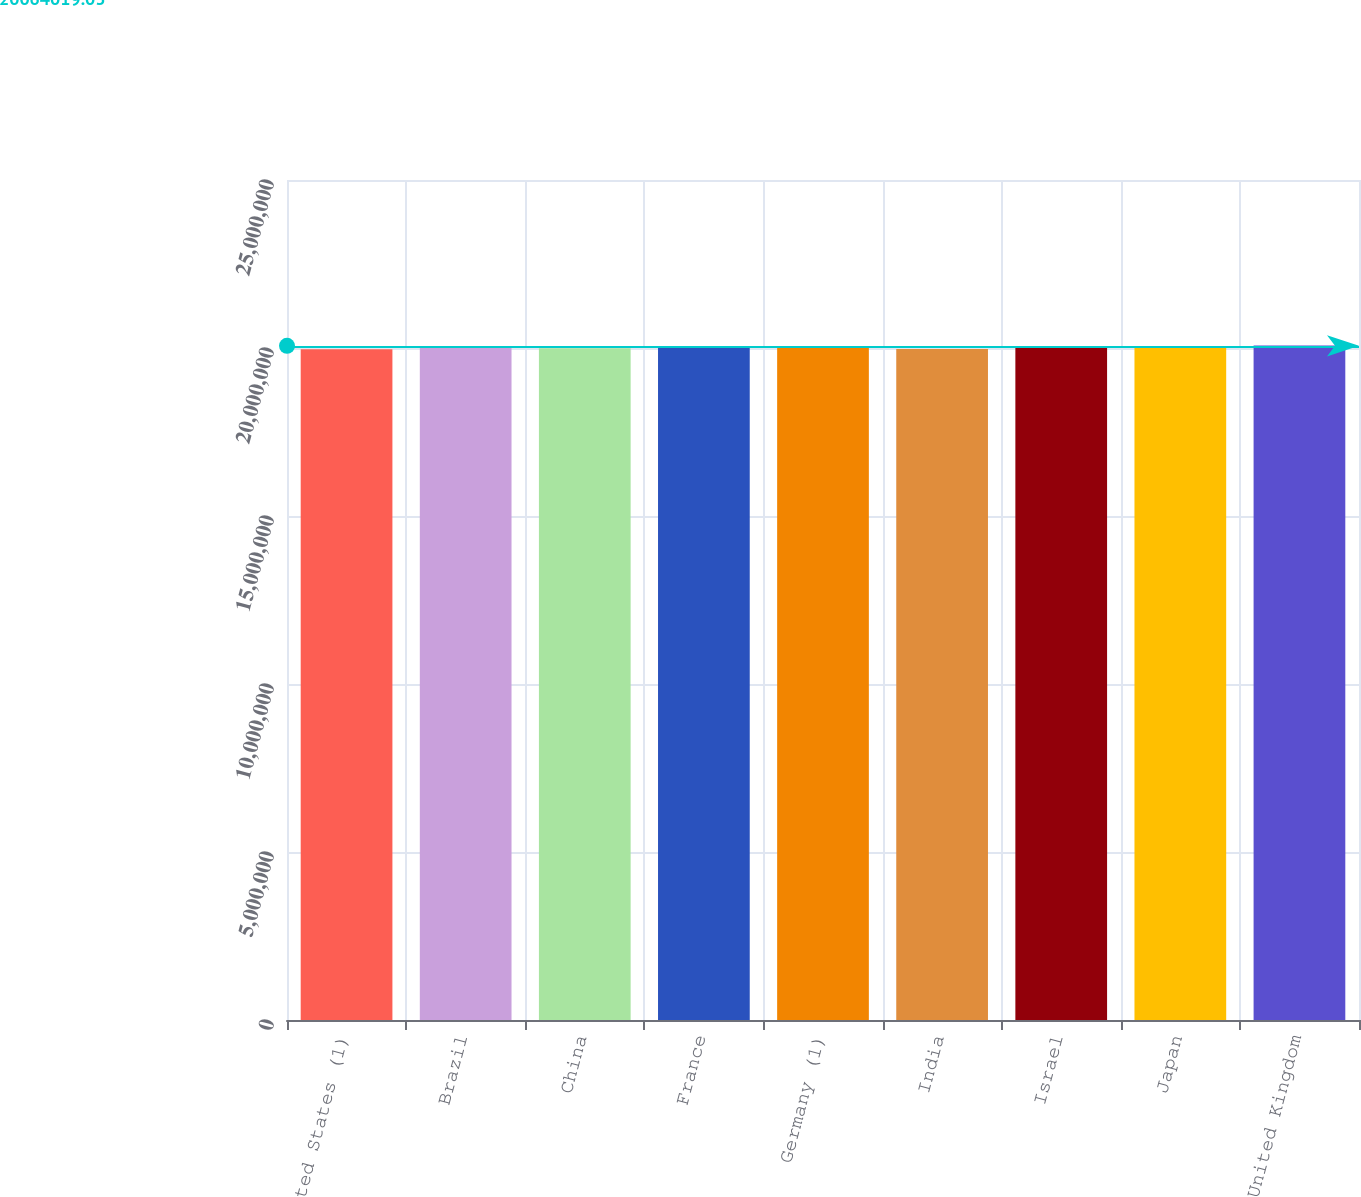Convert chart to OTSL. <chart><loc_0><loc_0><loc_500><loc_500><bar_chart><fcel>United States (1)<fcel>Brazil<fcel>China<fcel>France<fcel>Germany (1)<fcel>India<fcel>Israel<fcel>Japan<fcel>United Kingdom<nl><fcel>1.9962e+07<fcel>2.0032e+07<fcel>1.9992e+07<fcel>2.0042e+07<fcel>2.0052e+07<fcel>1.9972e+07<fcel>2.0062e+07<fcel>2.0022e+07<fcel>2.0072e+07<nl></chart> 